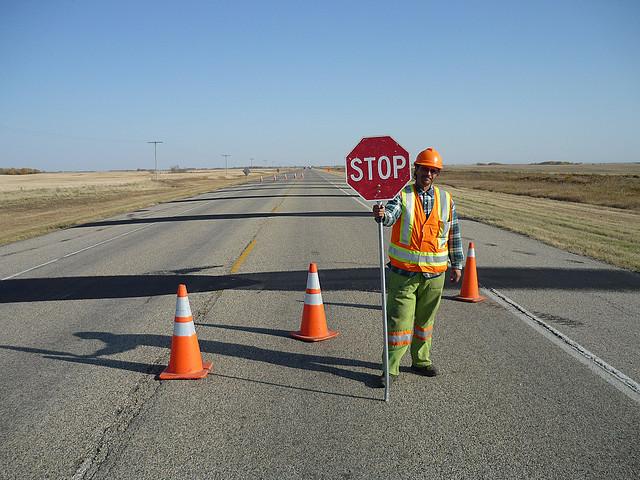What sign is shown in the image?
Give a very brief answer. Stop. What are these cars waiting for?
Keep it brief. Stop sign. Are there cars waiting to pass?
Keep it brief. Yes. 